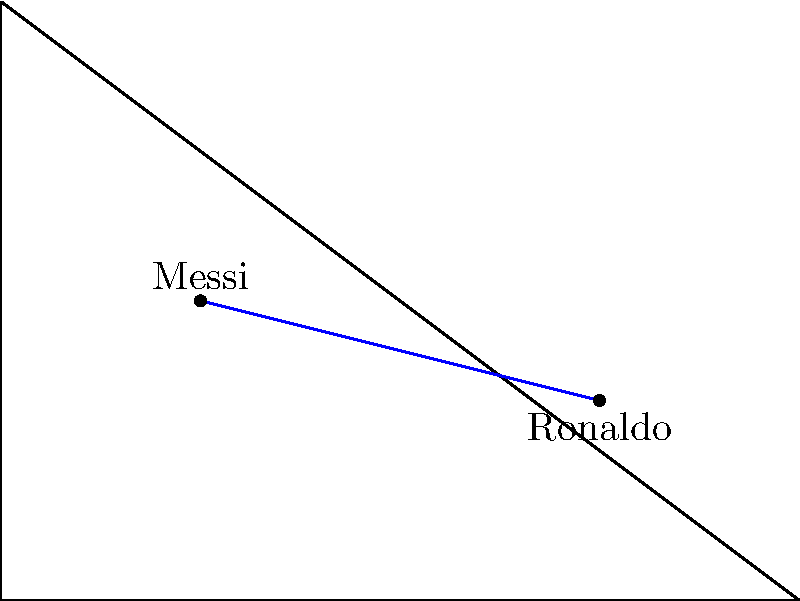During a crucial match, Messi starts running from point (2,3) while Ronaldo begins from (6,2). Messi's path can be represented by the equation $y=3x$, while Ronaldo's path is given by $y=-\frac{1}{4}x+\frac{11}{4}$. At what point (x,y) will their paths intersect? To find the intersection point of Messi and Ronaldo's paths, we need to solve the system of equations:

1) Messi's path: $y = 3x$
2) Ronaldo's path: $y = -\frac{1}{4}x + \frac{11}{4}$

Step 1: Set the equations equal to each other
$3x = -\frac{1}{4}x + \frac{11}{4}$

Step 2: Multiply both sides by 4 to eliminate fractions
$12x = -x + 11$

Step 3: Add x to both sides
$13x = 11$

Step 4: Divide both sides by 13
$x = \frac{11}{13}$

Step 5: Substitute this x-value into Messi's equation to find y
$y = 3(\frac{11}{13}) = \frac{33}{13}$

Therefore, the intersection point is $(\frac{11}{13}, \frac{33}{13})$.
Answer: $(\frac{11}{13}, \frac{33}{13})$ 